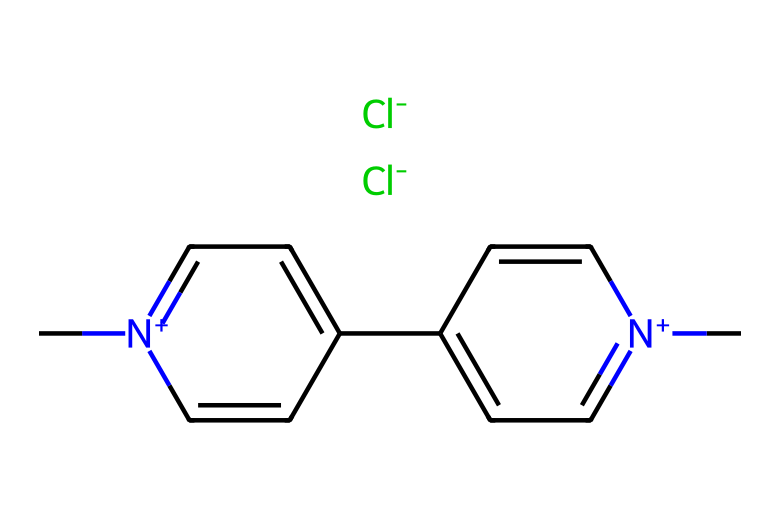What is the molecular formula of paraquat? To determine the molecular formula from the SMILES representation, I identify all the atoms present. The structure indicates there are two nitrogen (N) atoms, eight carbon (C) atoms, and two chlorine (Cl) atoms along with hydrogen which fills in the rest. Therefore, the molecular formula is C8H10Cl2N2.
Answer: C8H10Cl2N2 How many nitrogen atoms are present in paraquat? By examining the SMILES structure, nitrogen atoms are represented by the "n" and "N" notations, indicating that there are two nitrogen atoms.
Answer: 2 What type of herbicide is paraquat classified as? Paraquat is known as a non-selective herbicide, meaning it kills all plant types rather than targeting specific ones. This classification is based on its mode of action within the chemical structure.
Answer: non-selective What is the primary mechanism of action for paraquat? Paraquat primarily acts through the generation of reactive oxygen species (ROS) that disrupt cellular processes, ultimately leading to plant death. This mechanism can be derived from its interactions with photosynthesis and oxidative stress pathways, indicated by its chemical structure.
Answer: generation of reactive oxygen species What functional groups are present in paraquat? The chemical's structure reveals two quaternary ammonium groups due to the nitrogen atoms being positively charged and directly bonded to carbon atoms. These groups are characteristic for its structure as they influence its herbicidal properties.
Answer: quaternary ammonium groups How does the presence of chlorine in paraquat affect its herbicidal activity? Chlorine increases the toxicity of paraquat by enhancing its interaction with plant cellular components, thereby facilitating its herbicidal activity. Its structural placement assists in the binding to target sites in plants.
Answer: increases toxicity 